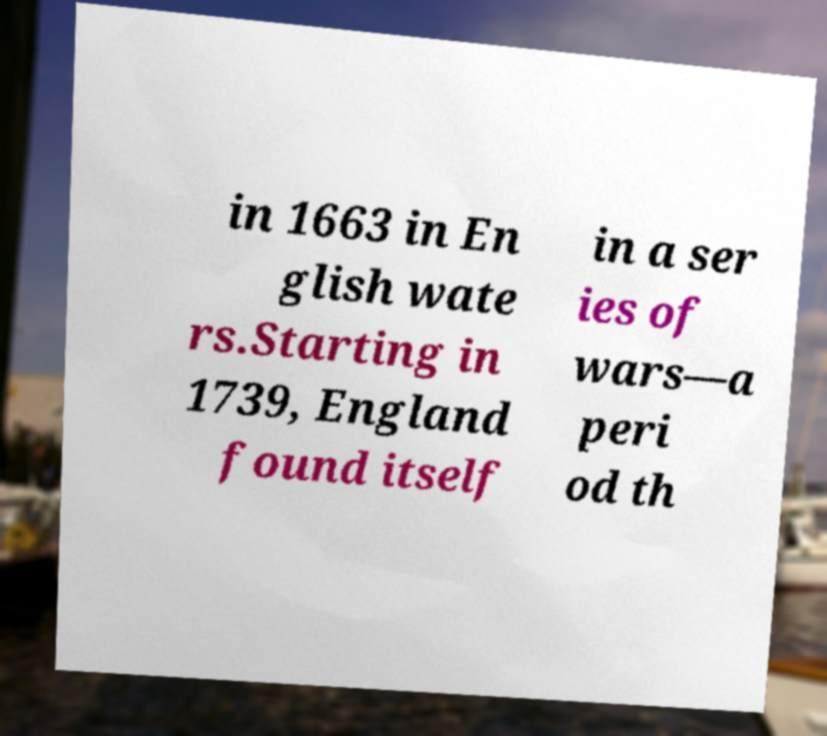What messages or text are displayed in this image? I need them in a readable, typed format. in 1663 in En glish wate rs.Starting in 1739, England found itself in a ser ies of wars—a peri od th 